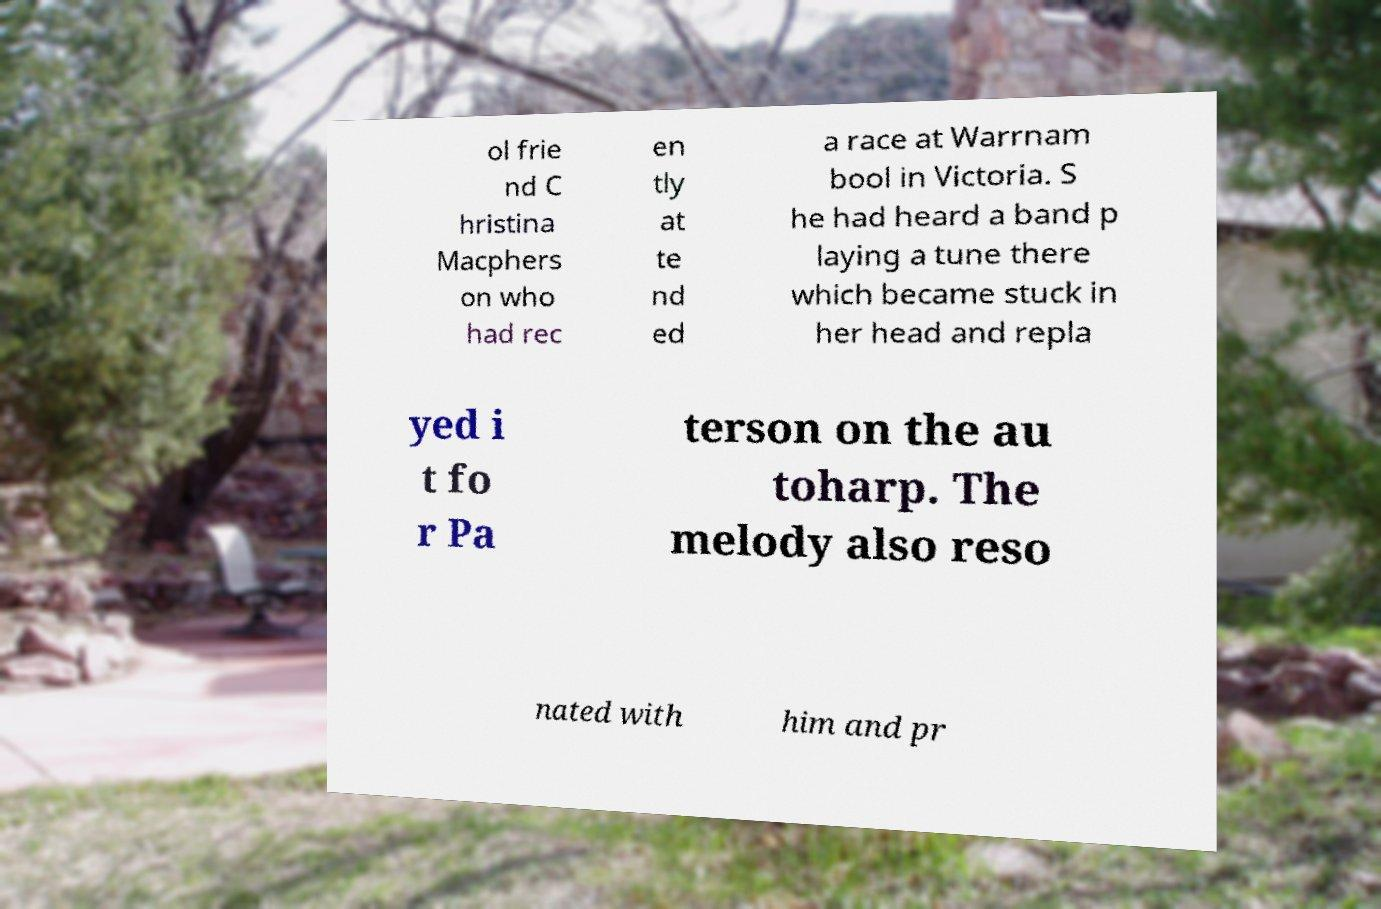For documentation purposes, I need the text within this image transcribed. Could you provide that? ol frie nd C hristina Macphers on who had rec en tly at te nd ed a race at Warrnam bool in Victoria. S he had heard a band p laying a tune there which became stuck in her head and repla yed i t fo r Pa terson on the au toharp. The melody also reso nated with him and pr 